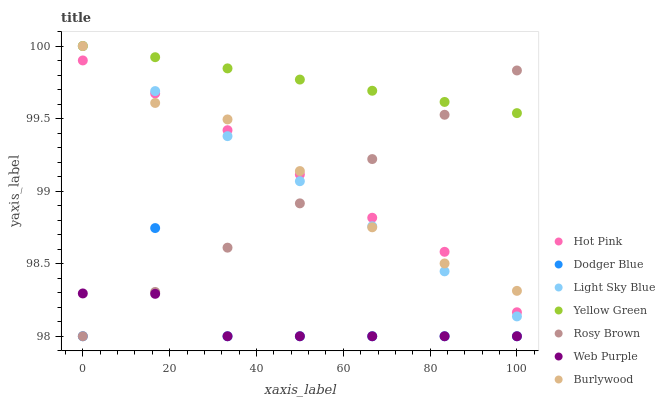Does Web Purple have the minimum area under the curve?
Answer yes or no. Yes. Does Yellow Green have the maximum area under the curve?
Answer yes or no. Yes. Does Burlywood have the minimum area under the curve?
Answer yes or no. No. Does Burlywood have the maximum area under the curve?
Answer yes or no. No. Is Yellow Green the smoothest?
Answer yes or no. Yes. Is Dodger Blue the roughest?
Answer yes or no. Yes. Is Burlywood the smoothest?
Answer yes or no. No. Is Burlywood the roughest?
Answer yes or no. No. Does Rosy Brown have the lowest value?
Answer yes or no. Yes. Does Burlywood have the lowest value?
Answer yes or no. No. Does Light Sky Blue have the highest value?
Answer yes or no. Yes. Does Rosy Brown have the highest value?
Answer yes or no. No. Is Dodger Blue less than Burlywood?
Answer yes or no. Yes. Is Light Sky Blue greater than Dodger Blue?
Answer yes or no. Yes. Does Light Sky Blue intersect Burlywood?
Answer yes or no. Yes. Is Light Sky Blue less than Burlywood?
Answer yes or no. No. Is Light Sky Blue greater than Burlywood?
Answer yes or no. No. Does Dodger Blue intersect Burlywood?
Answer yes or no. No. 